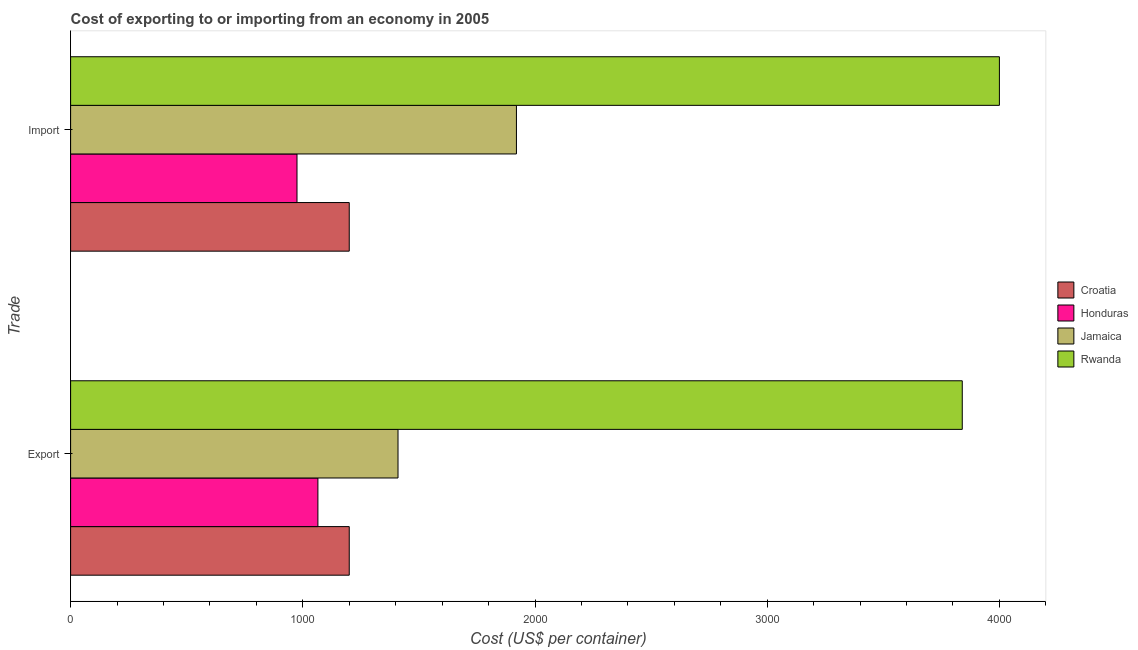How many different coloured bars are there?
Your answer should be compact. 4. How many groups of bars are there?
Provide a short and direct response. 2. Are the number of bars on each tick of the Y-axis equal?
Provide a succinct answer. Yes. How many bars are there on the 1st tick from the bottom?
Make the answer very short. 4. What is the label of the 2nd group of bars from the top?
Your response must be concise. Export. What is the export cost in Rwanda?
Your answer should be compact. 3840. Across all countries, what is the maximum export cost?
Keep it short and to the point. 3840. Across all countries, what is the minimum export cost?
Ensure brevity in your answer.  1065. In which country was the import cost maximum?
Give a very brief answer. Rwanda. In which country was the import cost minimum?
Keep it short and to the point. Honduras. What is the total import cost in the graph?
Your response must be concise. 8095. What is the difference between the import cost in Rwanda and that in Jamaica?
Provide a short and direct response. 2080. What is the difference between the export cost in Jamaica and the import cost in Honduras?
Your answer should be compact. 435. What is the average export cost per country?
Ensure brevity in your answer.  1878.75. What is the difference between the export cost and import cost in Rwanda?
Your response must be concise. -160. In how many countries, is the export cost greater than 1600 US$?
Your answer should be very brief. 1. What is the ratio of the export cost in Jamaica to that in Croatia?
Give a very brief answer. 1.18. Is the import cost in Honduras less than that in Rwanda?
Make the answer very short. Yes. What does the 4th bar from the top in Export represents?
Your answer should be very brief. Croatia. What does the 3rd bar from the bottom in Import represents?
Provide a short and direct response. Jamaica. How many countries are there in the graph?
Your answer should be compact. 4. Does the graph contain grids?
Offer a very short reply. No. What is the title of the graph?
Keep it short and to the point. Cost of exporting to or importing from an economy in 2005. Does "Ethiopia" appear as one of the legend labels in the graph?
Keep it short and to the point. No. What is the label or title of the X-axis?
Provide a short and direct response. Cost (US$ per container). What is the label or title of the Y-axis?
Provide a short and direct response. Trade. What is the Cost (US$ per container) of Croatia in Export?
Offer a very short reply. 1200. What is the Cost (US$ per container) of Honduras in Export?
Make the answer very short. 1065. What is the Cost (US$ per container) in Jamaica in Export?
Your answer should be compact. 1410. What is the Cost (US$ per container) of Rwanda in Export?
Provide a succinct answer. 3840. What is the Cost (US$ per container) in Croatia in Import?
Your answer should be very brief. 1200. What is the Cost (US$ per container) in Honduras in Import?
Offer a very short reply. 975. What is the Cost (US$ per container) in Jamaica in Import?
Give a very brief answer. 1920. What is the Cost (US$ per container) of Rwanda in Import?
Your answer should be compact. 4000. Across all Trade, what is the maximum Cost (US$ per container) of Croatia?
Your answer should be very brief. 1200. Across all Trade, what is the maximum Cost (US$ per container) of Honduras?
Your response must be concise. 1065. Across all Trade, what is the maximum Cost (US$ per container) of Jamaica?
Keep it short and to the point. 1920. Across all Trade, what is the maximum Cost (US$ per container) of Rwanda?
Ensure brevity in your answer.  4000. Across all Trade, what is the minimum Cost (US$ per container) in Croatia?
Offer a very short reply. 1200. Across all Trade, what is the minimum Cost (US$ per container) in Honduras?
Give a very brief answer. 975. Across all Trade, what is the minimum Cost (US$ per container) of Jamaica?
Provide a short and direct response. 1410. Across all Trade, what is the minimum Cost (US$ per container) of Rwanda?
Ensure brevity in your answer.  3840. What is the total Cost (US$ per container) of Croatia in the graph?
Offer a terse response. 2400. What is the total Cost (US$ per container) of Honduras in the graph?
Your answer should be very brief. 2040. What is the total Cost (US$ per container) of Jamaica in the graph?
Your answer should be very brief. 3330. What is the total Cost (US$ per container) in Rwanda in the graph?
Provide a succinct answer. 7840. What is the difference between the Cost (US$ per container) of Honduras in Export and that in Import?
Give a very brief answer. 90. What is the difference between the Cost (US$ per container) in Jamaica in Export and that in Import?
Make the answer very short. -510. What is the difference between the Cost (US$ per container) in Rwanda in Export and that in Import?
Ensure brevity in your answer.  -160. What is the difference between the Cost (US$ per container) of Croatia in Export and the Cost (US$ per container) of Honduras in Import?
Provide a short and direct response. 225. What is the difference between the Cost (US$ per container) of Croatia in Export and the Cost (US$ per container) of Jamaica in Import?
Make the answer very short. -720. What is the difference between the Cost (US$ per container) in Croatia in Export and the Cost (US$ per container) in Rwanda in Import?
Your response must be concise. -2800. What is the difference between the Cost (US$ per container) in Honduras in Export and the Cost (US$ per container) in Jamaica in Import?
Make the answer very short. -855. What is the difference between the Cost (US$ per container) of Honduras in Export and the Cost (US$ per container) of Rwanda in Import?
Your answer should be compact. -2935. What is the difference between the Cost (US$ per container) in Jamaica in Export and the Cost (US$ per container) in Rwanda in Import?
Make the answer very short. -2590. What is the average Cost (US$ per container) in Croatia per Trade?
Your answer should be compact. 1200. What is the average Cost (US$ per container) in Honduras per Trade?
Ensure brevity in your answer.  1020. What is the average Cost (US$ per container) of Jamaica per Trade?
Your answer should be very brief. 1665. What is the average Cost (US$ per container) of Rwanda per Trade?
Offer a very short reply. 3920. What is the difference between the Cost (US$ per container) in Croatia and Cost (US$ per container) in Honduras in Export?
Offer a terse response. 135. What is the difference between the Cost (US$ per container) in Croatia and Cost (US$ per container) in Jamaica in Export?
Provide a short and direct response. -210. What is the difference between the Cost (US$ per container) of Croatia and Cost (US$ per container) of Rwanda in Export?
Make the answer very short. -2640. What is the difference between the Cost (US$ per container) of Honduras and Cost (US$ per container) of Jamaica in Export?
Provide a succinct answer. -345. What is the difference between the Cost (US$ per container) of Honduras and Cost (US$ per container) of Rwanda in Export?
Your answer should be very brief. -2775. What is the difference between the Cost (US$ per container) of Jamaica and Cost (US$ per container) of Rwanda in Export?
Ensure brevity in your answer.  -2430. What is the difference between the Cost (US$ per container) in Croatia and Cost (US$ per container) in Honduras in Import?
Your answer should be very brief. 225. What is the difference between the Cost (US$ per container) in Croatia and Cost (US$ per container) in Jamaica in Import?
Keep it short and to the point. -720. What is the difference between the Cost (US$ per container) of Croatia and Cost (US$ per container) of Rwanda in Import?
Ensure brevity in your answer.  -2800. What is the difference between the Cost (US$ per container) of Honduras and Cost (US$ per container) of Jamaica in Import?
Your response must be concise. -945. What is the difference between the Cost (US$ per container) of Honduras and Cost (US$ per container) of Rwanda in Import?
Offer a very short reply. -3025. What is the difference between the Cost (US$ per container) of Jamaica and Cost (US$ per container) of Rwanda in Import?
Make the answer very short. -2080. What is the ratio of the Cost (US$ per container) in Honduras in Export to that in Import?
Keep it short and to the point. 1.09. What is the ratio of the Cost (US$ per container) in Jamaica in Export to that in Import?
Offer a very short reply. 0.73. What is the ratio of the Cost (US$ per container) of Rwanda in Export to that in Import?
Provide a short and direct response. 0.96. What is the difference between the highest and the second highest Cost (US$ per container) in Honduras?
Offer a very short reply. 90. What is the difference between the highest and the second highest Cost (US$ per container) in Jamaica?
Your response must be concise. 510. What is the difference between the highest and the second highest Cost (US$ per container) in Rwanda?
Keep it short and to the point. 160. What is the difference between the highest and the lowest Cost (US$ per container) of Jamaica?
Provide a succinct answer. 510. What is the difference between the highest and the lowest Cost (US$ per container) in Rwanda?
Offer a terse response. 160. 